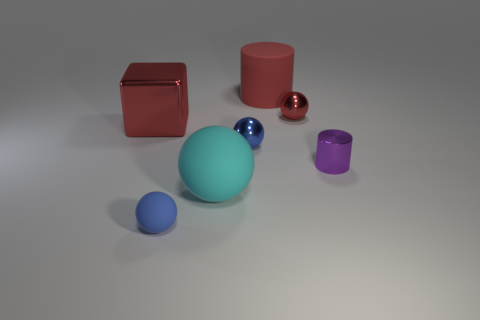What could be the possible use of these objects in a real-world setting? These objects might be used for various purposes. For instance, they could serve as visual aids for educational purposes, such as teaching geometry, volume, and spatial relationships. They could also be part of a modern art installation, or used in computer graphics for rendering and lighting practice. 